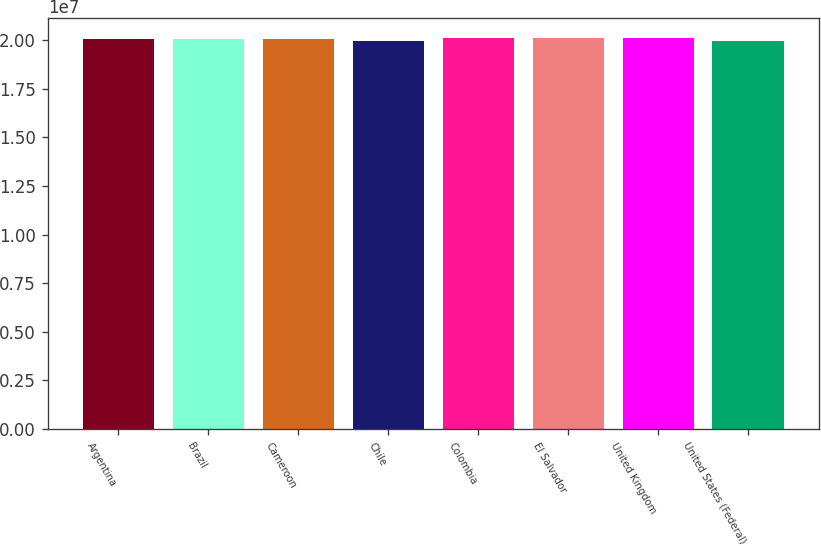<chart> <loc_0><loc_0><loc_500><loc_500><bar_chart><fcel>Argentina<fcel>Brazil<fcel>Cameroon<fcel>Chile<fcel>Colombia<fcel>El Salvador<fcel>United Kingdom<fcel>United States (Federal)<nl><fcel>2.0052e+07<fcel>2.0066e+07<fcel>2.008e+07<fcel>1.9982e+07<fcel>2.0094e+07<fcel>2.0108e+07<fcel>2.0122e+07<fcel>1.9942e+07<nl></chart> 